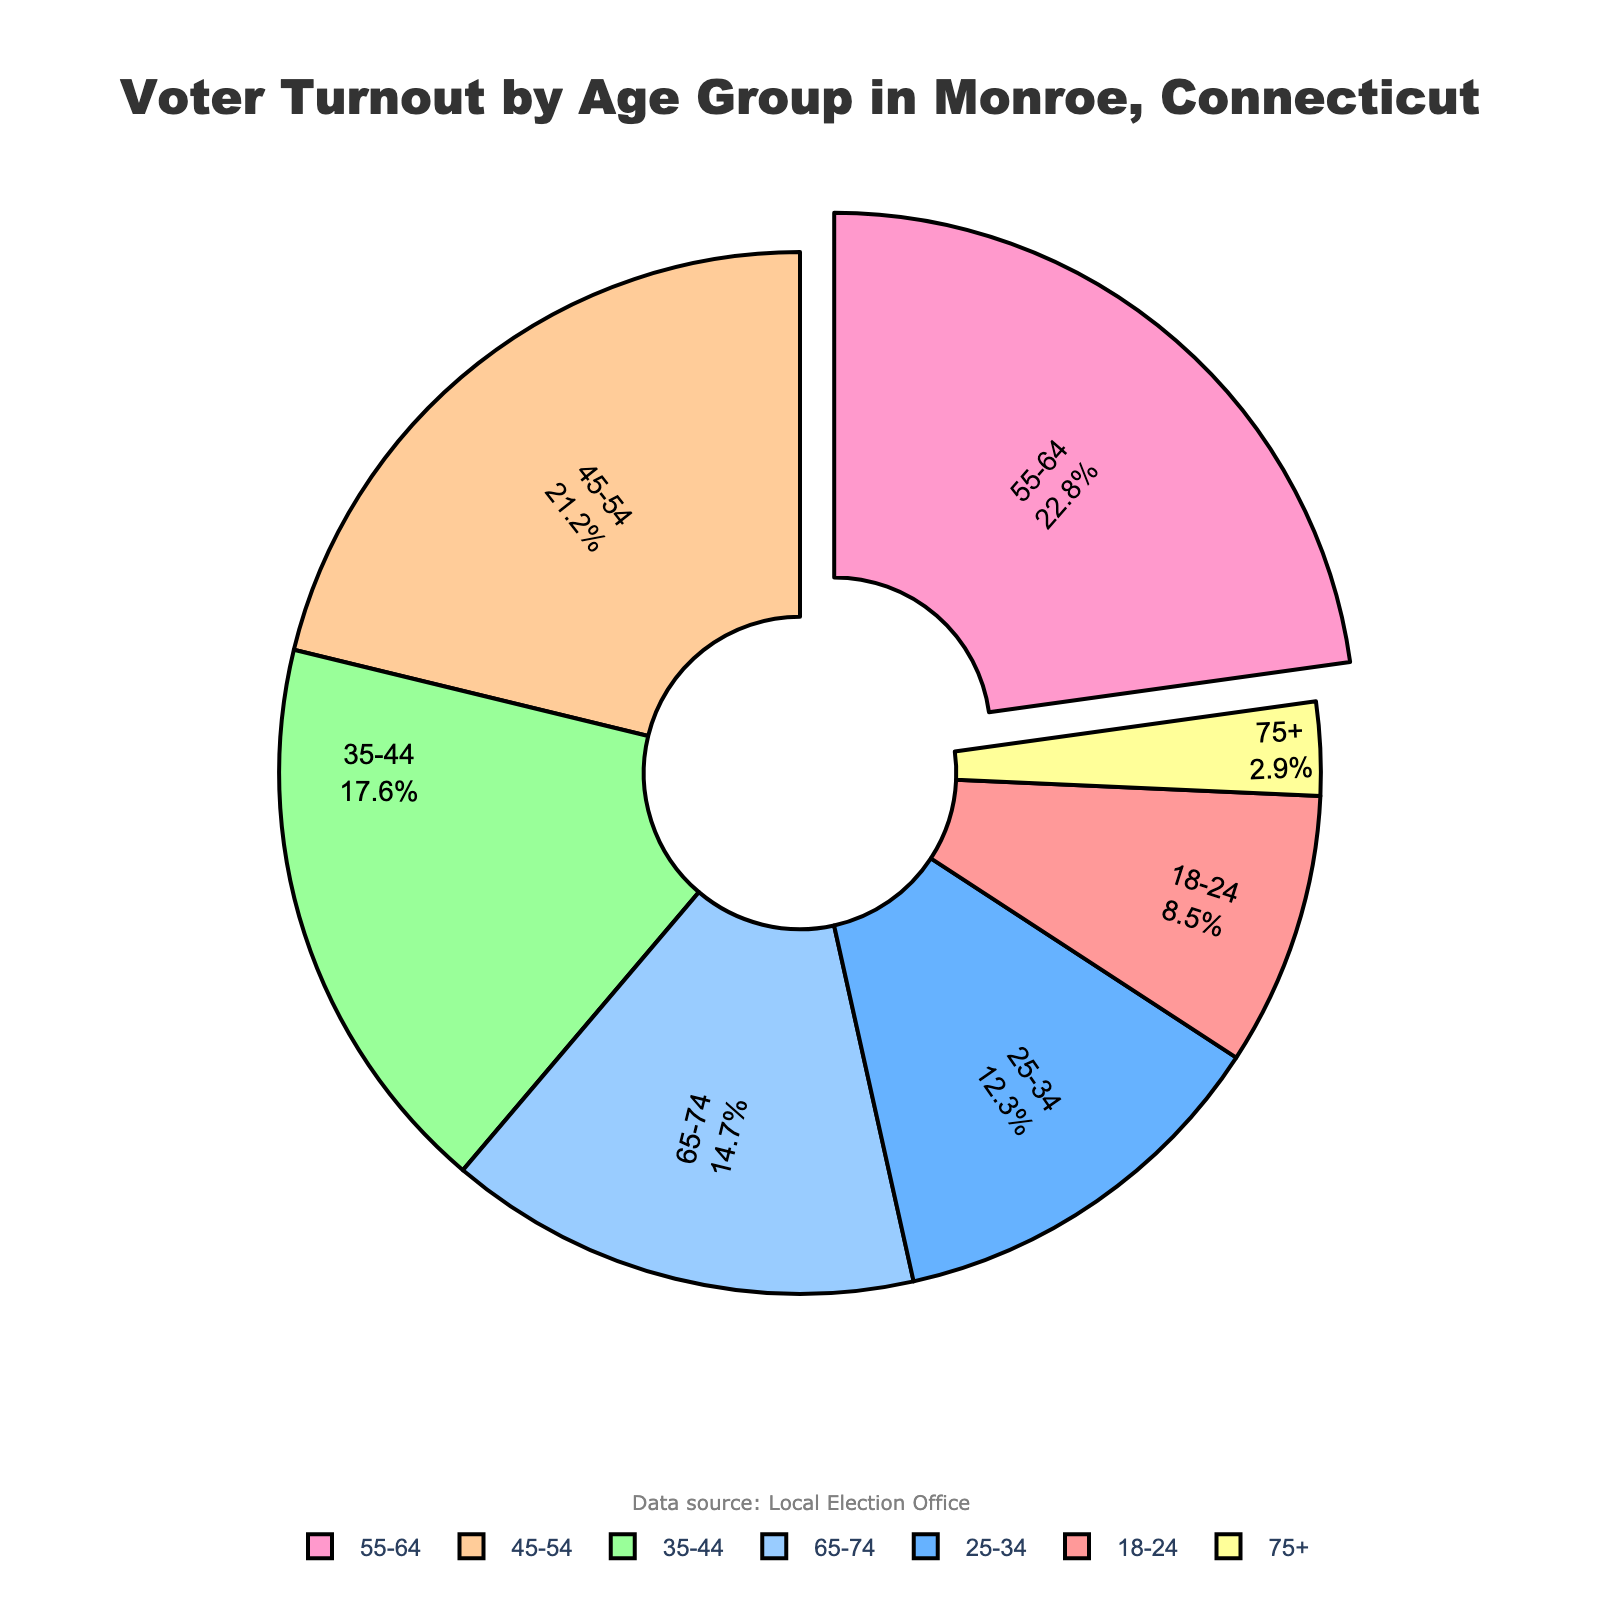What is the age group with the highest voter turnout? The age group with the highest voter turnout can be identified by finding the largest value in the 'Voter Turnout Percentage' column. In this case, it is 55-64 with 22.8%.
Answer: 55-64 What is the combined voter turnout percentage for age groups 18-24 and 75+? To find the combined percentage, add the percentages of the 18-24 group (8.5) and the 75+ group (2.9): 8.5 + 2.9 = 11.4.
Answer: 11.4 Which age group has a lower voter turnout percentage, 25-34 or 65-74? By comparing the percentages for the 25-34 group (12.3) and the 65-74 group (14.7), we see that 25-34 is lower.
Answer: 25-34 How much higher is the voter turnout percentage for the 55-64 age group compared to the 18-24 age group? Subtract the voter turnout percentage for the 18-24 group (8.5) from that of the 55-64 group (22.8): 22.8 - 8.5 = 14.3.
Answer: 14.3 What is the median voter turnout percentage among all age groups? To find the median, list the percentages in ascending order: 2.9, 8.5, 12.3, 14.7, 17.6, 21.2, 22.8. The median value is the one in the middle, which is 14.7.
Answer: 14.7 If you add the voter turnout percentages of the three highest categories, what is the result? The three highest voter turnout percentages are 22.8 (55-64), 21.2 (45-54), and 17.6 (35-44). Summing these gives 22.8 + 21.2 + 17.6 = 61.6.
Answer: 61.6 Which color represents the 35-44 age group? By looking at the pie chart, we can identify that this age group is represented by the third segment, which is green.
Answer: green Is the voter turnout percentage for the 65-74 age group higher or lower than the median voter turnout percentage? The median voter turnout percentage, as calculated earlier, is 14.7, which is equal to the percentage for the 65-74 age group.
Answer: equal Which two consecutive age groups have the greatest difference in voter turnout percentages? By comparing the differences between consecutive age groups: (12.3-8.5 = 3.8), (17.6-12.3 = 5.3), (21.2-17.6 = 3.6), (22.8-21.2 = 1.6), (14.7-22.8 = 8.1), (2.9-14.7 = -11.8). The greatest positive difference is between 25-34 and 35-44.
Answer: 25-34, 35-44 